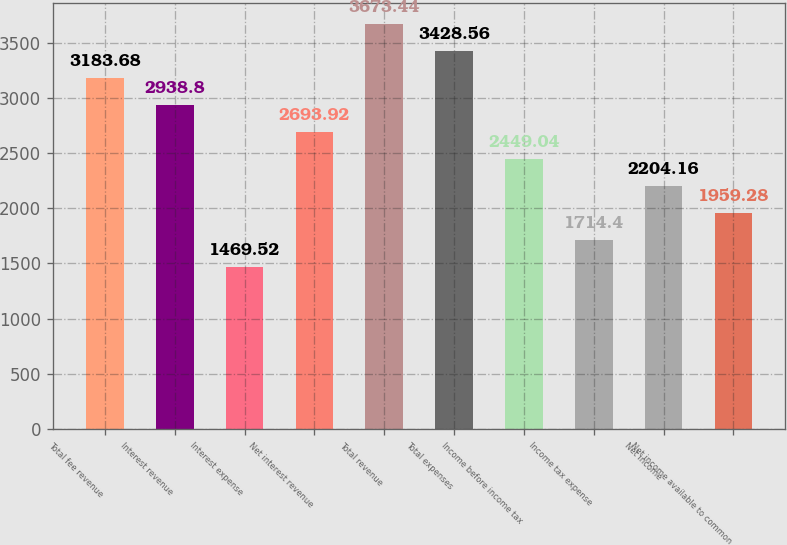Convert chart to OTSL. <chart><loc_0><loc_0><loc_500><loc_500><bar_chart><fcel>Total fee revenue<fcel>Interest revenue<fcel>Interest expense<fcel>Net interest revenue<fcel>Total revenue<fcel>Total expenses<fcel>Income before income tax<fcel>Income tax expense<fcel>Net income<fcel>Net income available to common<nl><fcel>3183.68<fcel>2938.8<fcel>1469.52<fcel>2693.92<fcel>3673.44<fcel>3428.56<fcel>2449.04<fcel>1714.4<fcel>2204.16<fcel>1959.28<nl></chart> 